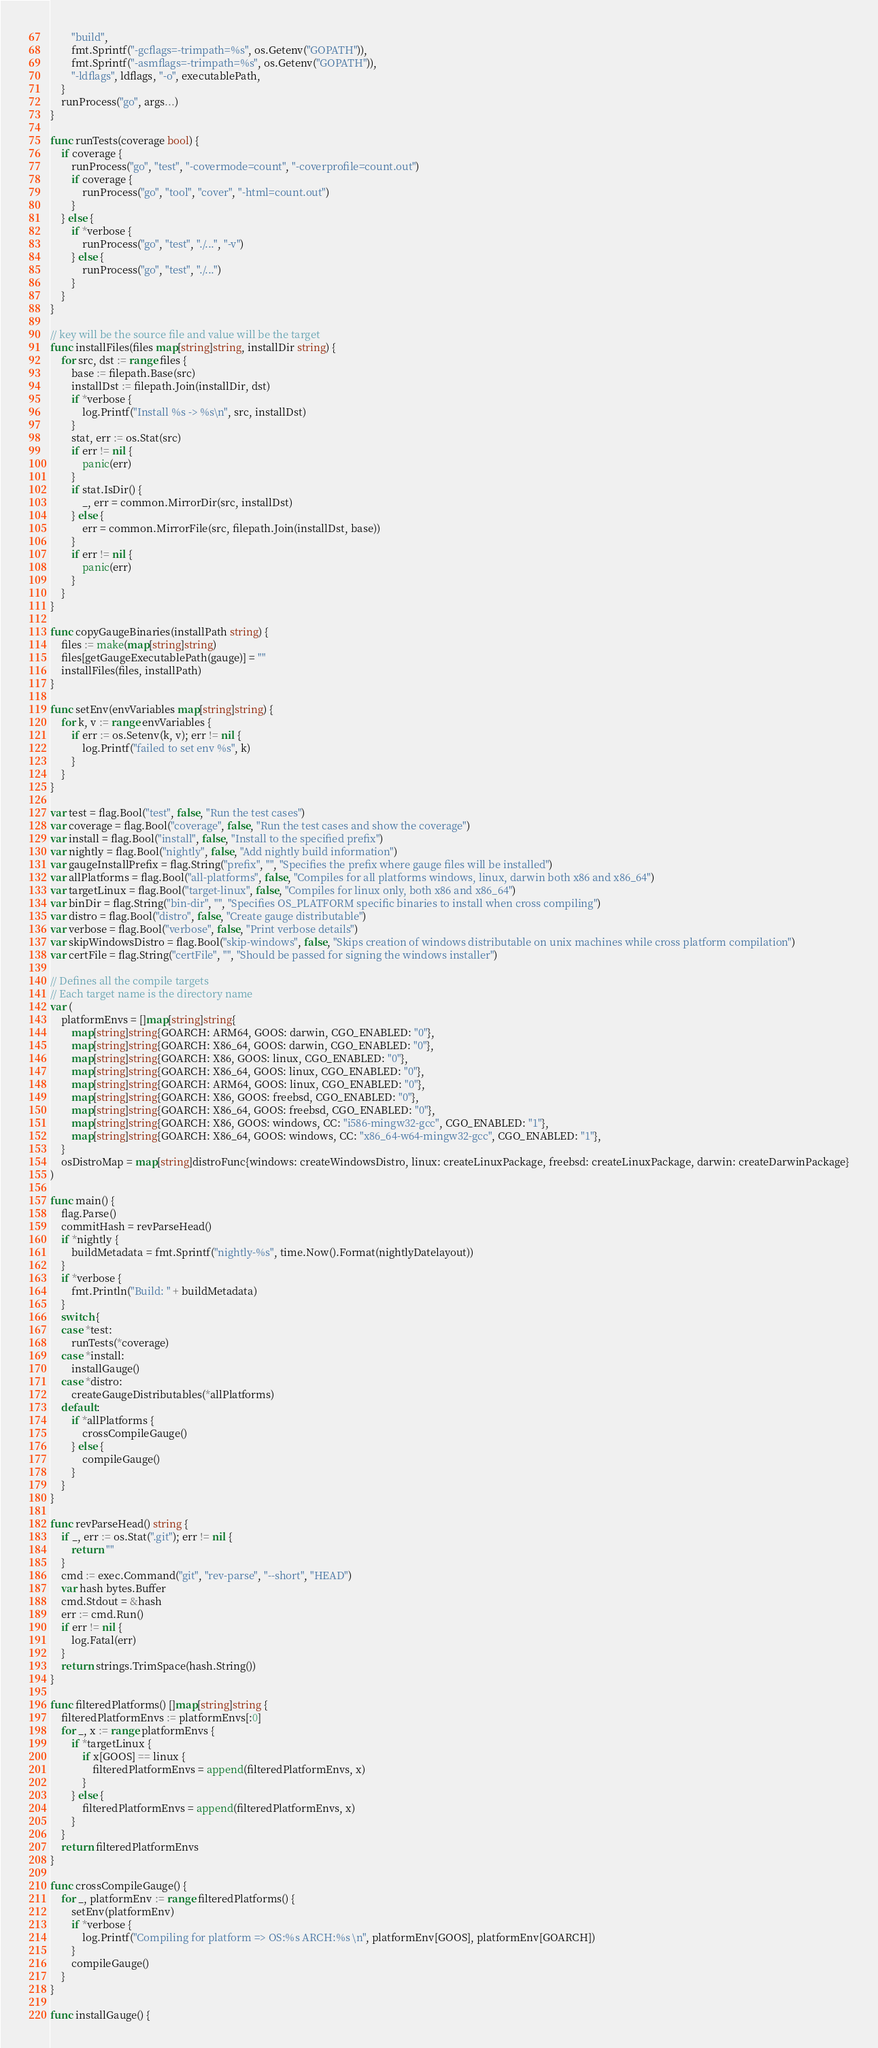Convert code to text. <code><loc_0><loc_0><loc_500><loc_500><_Go_>		"build",
		fmt.Sprintf("-gcflags=-trimpath=%s", os.Getenv("GOPATH")),
		fmt.Sprintf("-asmflags=-trimpath=%s", os.Getenv("GOPATH")),
		"-ldflags", ldflags, "-o", executablePath,
	}
	runProcess("go", args...)
}

func runTests(coverage bool) {
	if coverage {
		runProcess("go", "test", "-covermode=count", "-coverprofile=count.out")
		if coverage {
			runProcess("go", "tool", "cover", "-html=count.out")
		}
	} else {
		if *verbose {
			runProcess("go", "test", "./...", "-v")
		} else {
			runProcess("go", "test", "./...")
		}
	}
}

// key will be the source file and value will be the target
func installFiles(files map[string]string, installDir string) {
	for src, dst := range files {
		base := filepath.Base(src)
		installDst := filepath.Join(installDir, dst)
		if *verbose {
			log.Printf("Install %s -> %s\n", src, installDst)
		}
		stat, err := os.Stat(src)
		if err != nil {
			panic(err)
		}
		if stat.IsDir() {
			_, err = common.MirrorDir(src, installDst)
		} else {
			err = common.MirrorFile(src, filepath.Join(installDst, base))
		}
		if err != nil {
			panic(err)
		}
	}
}

func copyGaugeBinaries(installPath string) {
	files := make(map[string]string)
	files[getGaugeExecutablePath(gauge)] = ""
	installFiles(files, installPath)
}

func setEnv(envVariables map[string]string) {
	for k, v := range envVariables {
		if err := os.Setenv(k, v); err != nil {
			log.Printf("failed to set env %s", k)
		}
	}
}

var test = flag.Bool("test", false, "Run the test cases")
var coverage = flag.Bool("coverage", false, "Run the test cases and show the coverage")
var install = flag.Bool("install", false, "Install to the specified prefix")
var nightly = flag.Bool("nightly", false, "Add nightly build information")
var gaugeInstallPrefix = flag.String("prefix", "", "Specifies the prefix where gauge files will be installed")
var allPlatforms = flag.Bool("all-platforms", false, "Compiles for all platforms windows, linux, darwin both x86 and x86_64")
var targetLinux = flag.Bool("target-linux", false, "Compiles for linux only, both x86 and x86_64")
var binDir = flag.String("bin-dir", "", "Specifies OS_PLATFORM specific binaries to install when cross compiling")
var distro = flag.Bool("distro", false, "Create gauge distributable")
var verbose = flag.Bool("verbose", false, "Print verbose details")
var skipWindowsDistro = flag.Bool("skip-windows", false, "Skips creation of windows distributable on unix machines while cross platform compilation")
var certFile = flag.String("certFile", "", "Should be passed for signing the windows installer")

// Defines all the compile targets
// Each target name is the directory name
var (
	platformEnvs = []map[string]string{
		map[string]string{GOARCH: ARM64, GOOS: darwin, CGO_ENABLED: "0"},
		map[string]string{GOARCH: X86_64, GOOS: darwin, CGO_ENABLED: "0"},
		map[string]string{GOARCH: X86, GOOS: linux, CGO_ENABLED: "0"},
		map[string]string{GOARCH: X86_64, GOOS: linux, CGO_ENABLED: "0"},
		map[string]string{GOARCH: ARM64, GOOS: linux, CGO_ENABLED: "0"},
		map[string]string{GOARCH: X86, GOOS: freebsd, CGO_ENABLED: "0"},
		map[string]string{GOARCH: X86_64, GOOS: freebsd, CGO_ENABLED: "0"},
		map[string]string{GOARCH: X86, GOOS: windows, CC: "i586-mingw32-gcc", CGO_ENABLED: "1"},
		map[string]string{GOARCH: X86_64, GOOS: windows, CC: "x86_64-w64-mingw32-gcc", CGO_ENABLED: "1"},
	}
	osDistroMap = map[string]distroFunc{windows: createWindowsDistro, linux: createLinuxPackage, freebsd: createLinuxPackage, darwin: createDarwinPackage}
)

func main() {
	flag.Parse()
	commitHash = revParseHead()
	if *nightly {
		buildMetadata = fmt.Sprintf("nightly-%s", time.Now().Format(nightlyDatelayout))
	}
	if *verbose {
		fmt.Println("Build: " + buildMetadata)
	}
	switch {
	case *test:
		runTests(*coverage)
	case *install:
		installGauge()
	case *distro:
		createGaugeDistributables(*allPlatforms)
	default:
		if *allPlatforms {
			crossCompileGauge()
		} else {
			compileGauge()
		}
	}
}

func revParseHead() string {
	if _, err := os.Stat(".git"); err != nil {
		return ""
	}
	cmd := exec.Command("git", "rev-parse", "--short", "HEAD")
	var hash bytes.Buffer
	cmd.Stdout = &hash
	err := cmd.Run()
	if err != nil {
		log.Fatal(err)
	}
	return strings.TrimSpace(hash.String())
}

func filteredPlatforms() []map[string]string {
	filteredPlatformEnvs := platformEnvs[:0]
	for _, x := range platformEnvs {
		if *targetLinux {
			if x[GOOS] == linux {
				filteredPlatformEnvs = append(filteredPlatformEnvs, x)
			}
		} else {
			filteredPlatformEnvs = append(filteredPlatformEnvs, x)
		}
	}
	return filteredPlatformEnvs
}

func crossCompileGauge() {
	for _, platformEnv := range filteredPlatforms() {
		setEnv(platformEnv)
		if *verbose {
			log.Printf("Compiling for platform => OS:%s ARCH:%s \n", platformEnv[GOOS], platformEnv[GOARCH])
		}
		compileGauge()
	}
}

func installGauge() {</code> 